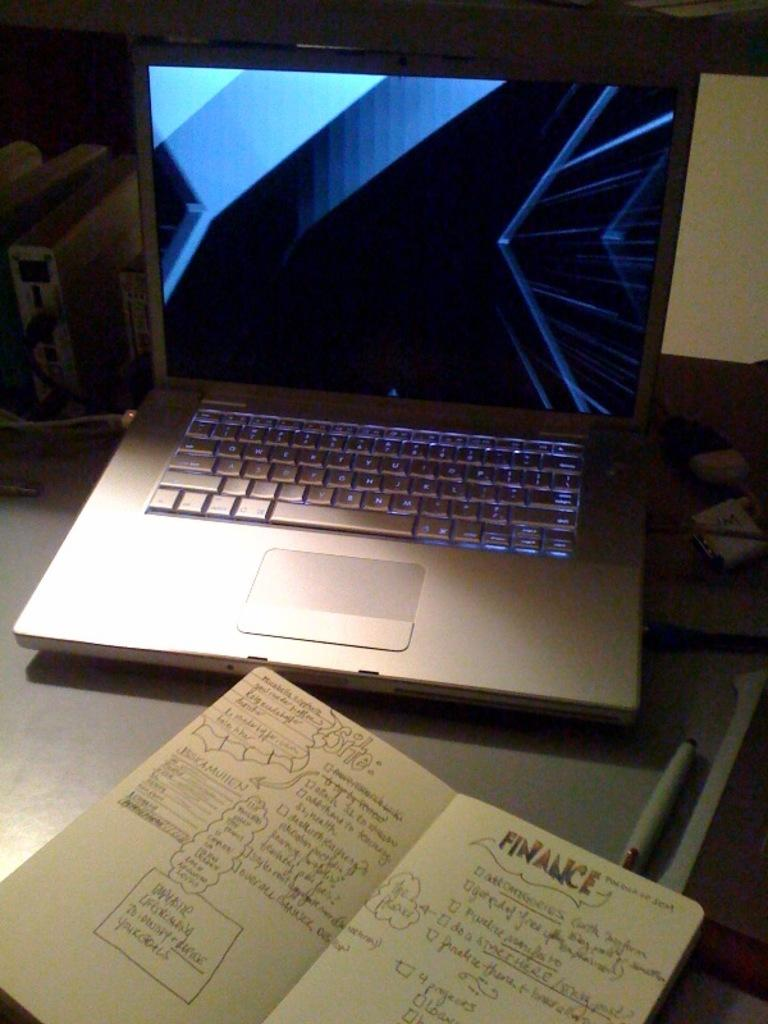<image>
Share a concise interpretation of the image provided. A notebook opened in front of a laptop has a page that is titled "finance." 